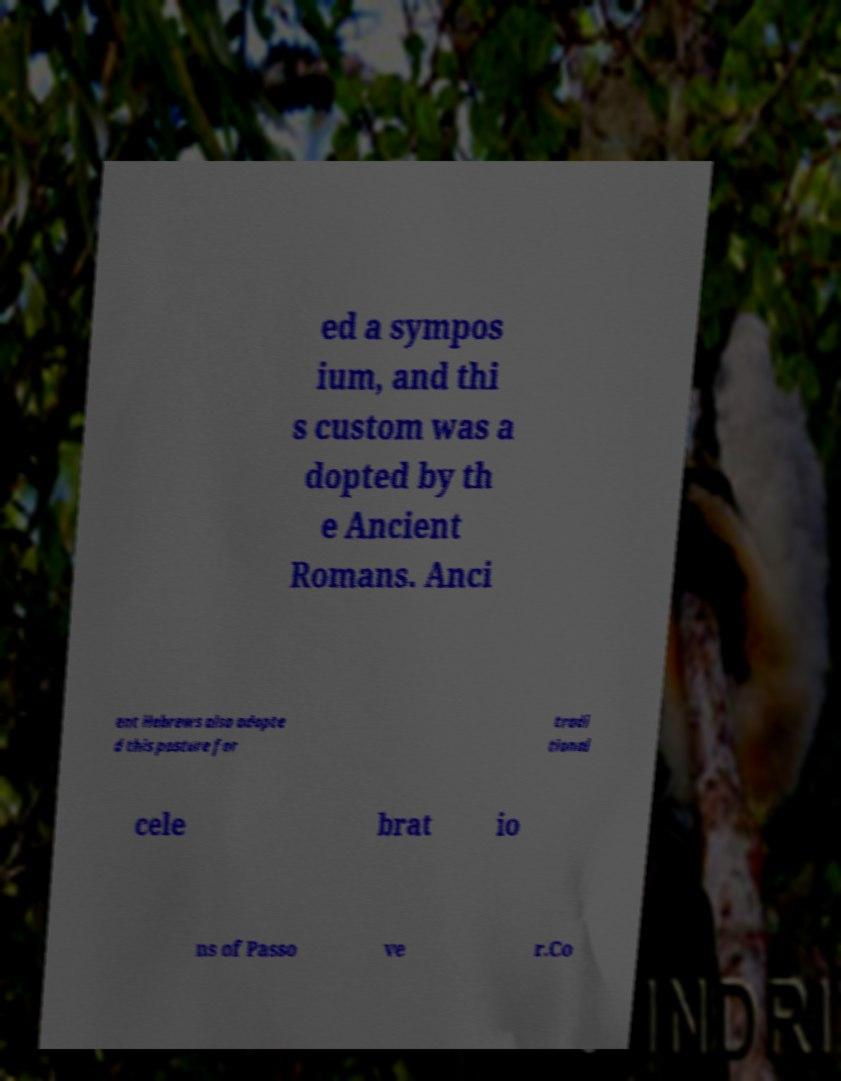There's text embedded in this image that I need extracted. Can you transcribe it verbatim? ed a sympos ium, and thi s custom was a dopted by th e Ancient Romans. Anci ent Hebrews also adopte d this posture for tradi tional cele brat io ns of Passo ve r.Co 